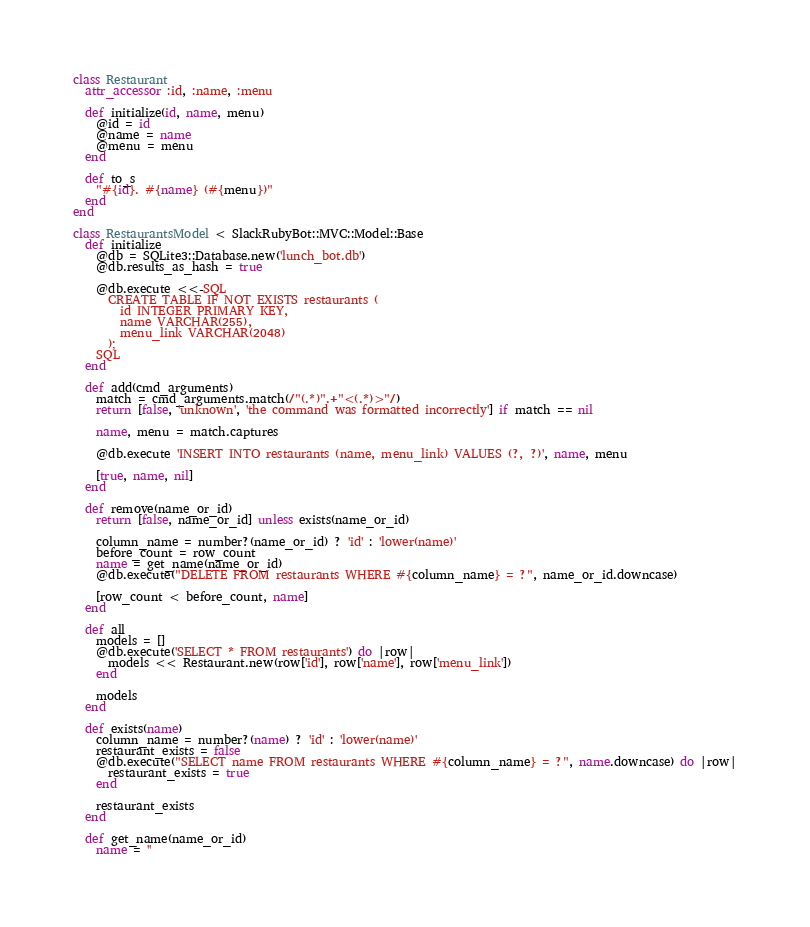<code> <loc_0><loc_0><loc_500><loc_500><_Ruby_>class Restaurant
  attr_accessor :id, :name, :menu

  def initialize(id, name, menu)
    @id = id
    @name = name
    @menu = menu
  end

  def to_s
    "#{id}. #{name} (#{menu})"
  end
end

class RestaurantsModel < SlackRubyBot::MVC::Model::Base
  def initialize
    @db = SQLite3::Database.new('lunch_bot.db')
    @db.results_as_hash = true

    @db.execute <<-SQL
      CREATE TABLE IF NOT EXISTS restaurants (
        id INTEGER PRIMARY KEY,
        name VARCHAR(255),
        menu_link VARCHAR(2048)
      );
    SQL
  end

  def add(cmd_arguments)
    match = cmd_arguments.match(/"(.*)".+"<(.*)>"/)
    return [false, 'unknown', 'the command was formatted incorrectly'] if match == nil

    name, menu = match.captures

    @db.execute 'INSERT INTO restaurants (name, menu_link) VALUES (?, ?)', name, menu

    [true, name, nil]
  end

  def remove(name_or_id)
    return [false, name_or_id] unless exists(name_or_id)

    column_name = number?(name_or_id) ? 'id' : 'lower(name)'
    before_count = row_count
    name = get_name(name_or_id)
    @db.execute("DELETE FROM restaurants WHERE #{column_name} = ?", name_or_id.downcase)

    [row_count < before_count, name]
  end

  def all
    models = []
    @db.execute('SELECT * FROM restaurants') do |row|
      models << Restaurant.new(row['id'], row['name'], row['menu_link'])
    end

    models
  end

  def exists(name)
    column_name = number?(name) ? 'id' : 'lower(name)'
    restaurant_exists = false
    @db.execute("SELECT name FROM restaurants WHERE #{column_name} = ?", name.downcase) do |row|
      restaurant_exists = true
    end

    restaurant_exists
  end

  def get_name(name_or_id)
    name = ''
</code> 